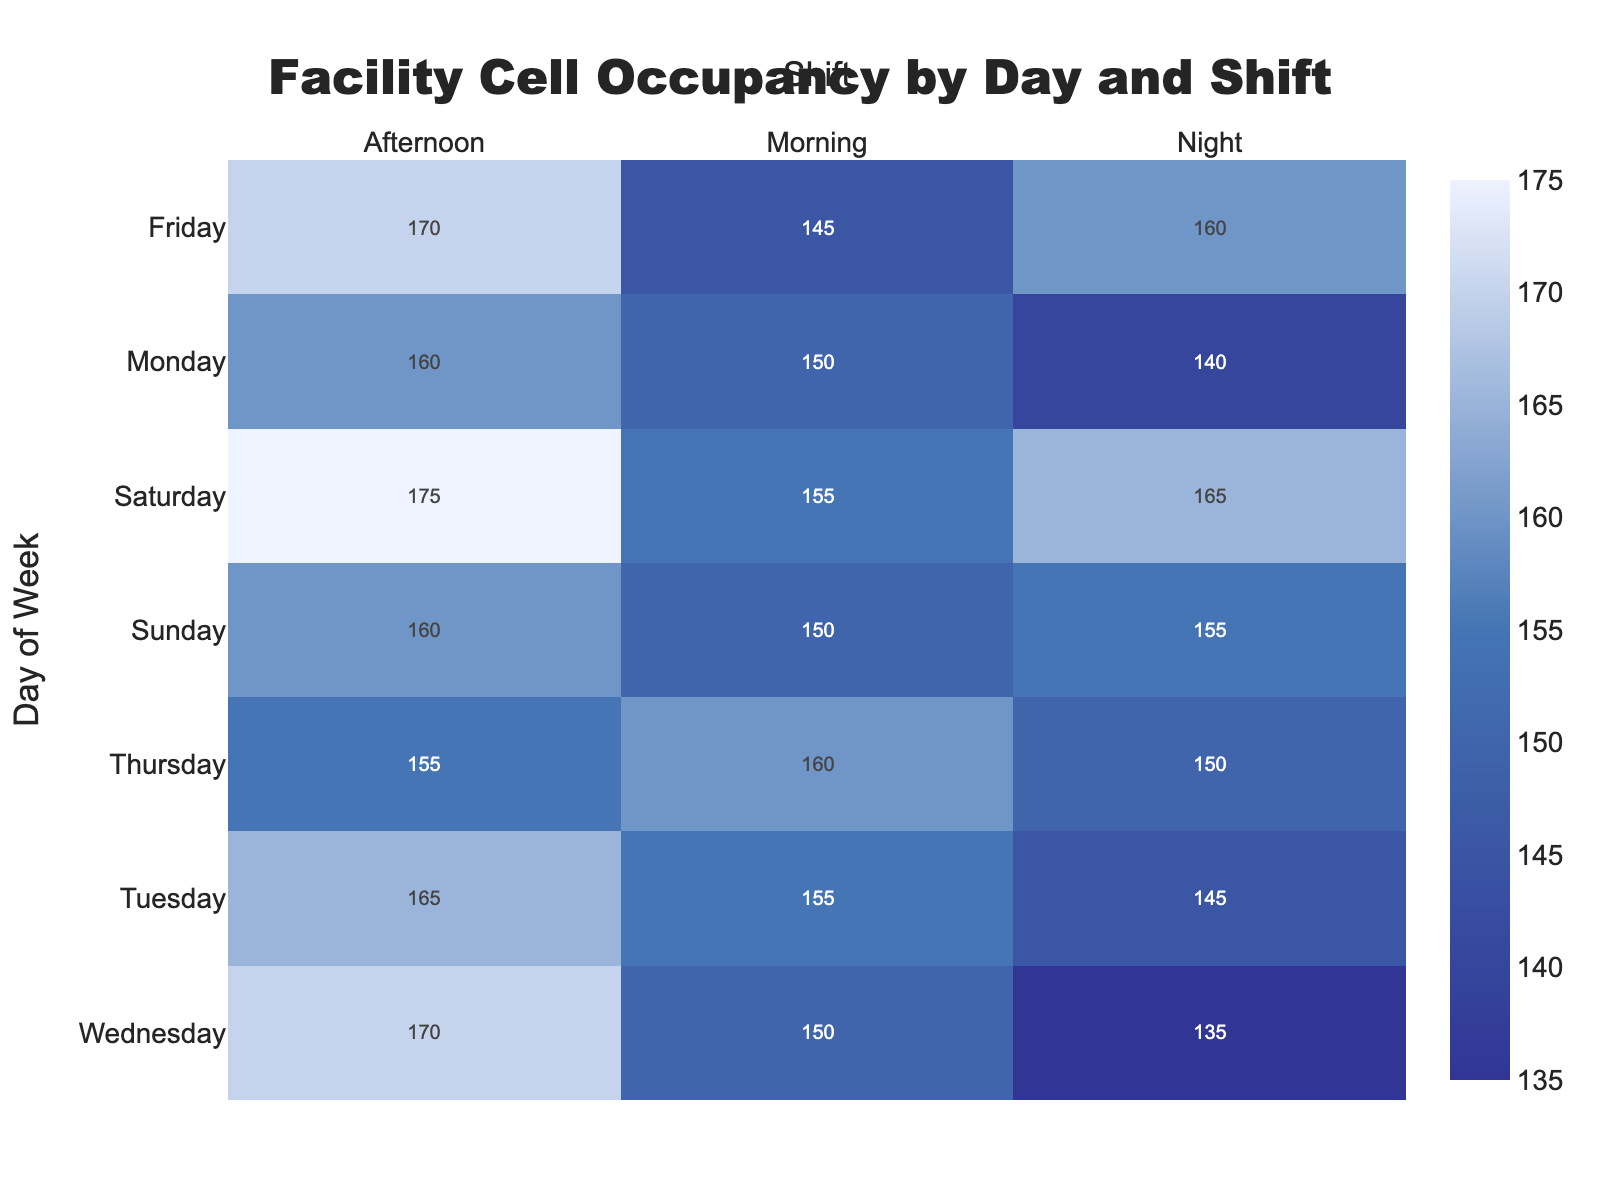What is the title of the heatmap? The title is prominently displayed at the top of the heatmap, generally in a larger font. It provides a summary or key insight of the visualized data. The title for this heatmap is "Facility Cell Occupancy by Day and Shift".
Answer: Facility Cell Occupancy by Day and Shift Which day and shift have the maximum cells occupied? To find this, look at the heatmap for the highest numerical value. The peak value shown is "175", occurring on "Saturday Afternoon".
Answer: Saturday Afternoon On which day and shift are the fewest cells occupied? By checking the heatmap for the lowest numerical value, you will see "135" being the lowest number of cells occupied. This occurs on "Wednesday Night".
Answer: Wednesday Night What is the average number of cells occupied on Monday? Adding the cells occupied for all shifts on Monday (150 + 160 + 140) gives 450. Dividing by the number of shifts (3) results in an average of 150.
Answer: 150 How does the number of cells occupied on Wednesday Morning compare to Thursday Morning? The heatmap shows 150 cells occupied on Wednesday Morning and 160 on Thursday Morning. Therefore, Thursday Morning has 10 more occupied cells than Wednesday Morning.
Answer: 10 more cells on Thursday Morning What is the difference in cell occupancy between Wednesday Afternoon and Wednesday Night? Wednesday Afternoon has 170 cells occupied and Wednesday Night has 135. Subtracting 135 from 170 gives a difference of 35.
Answer: 35 Is the cell occupancy greater on weekends (Saturday and Sunday) or weekdays (Monday to Friday) during the Afternoon shift? Summing up Afternoon shift cells for Saturday (175) and Sunday (160) gives 335. Summing those from Monday to Friday (160 + 165 + 170 + 155 + 170) gives 820. Weekdays have greater occupancy with a difference of 485 cells.
Answer: Weekdays What is the trend of cell occupancy from Monday to Sunday during the Night shift? Reviewing the heatmap values for Night shifts across all days shows a pattern: 140, 145, 135, 150, 160, 165, 155. The values generally trend upwards midweek before slightly dropping by Sunday.
Answer: Increases midweek, then drops slightly on Sunday Which shift generally shows the highest cell occupancy during the week? Observing the heatmap, the Afternoon shift on most days shows higher cell occupancy values compared to Morning and Night shifts, with maximums reaching 175.
Answer: Afternoon Do incident reports correlate with high cell occupancy? Evaluating the table data, high occupancy days like Wednesday Afternoon (170 cells, 4 incidents) and Saturday Afternoon (175 cells, 3 incidents) often show multiple incidents, suggesting a positive correlation.
Answer: Yes, generally correlated 